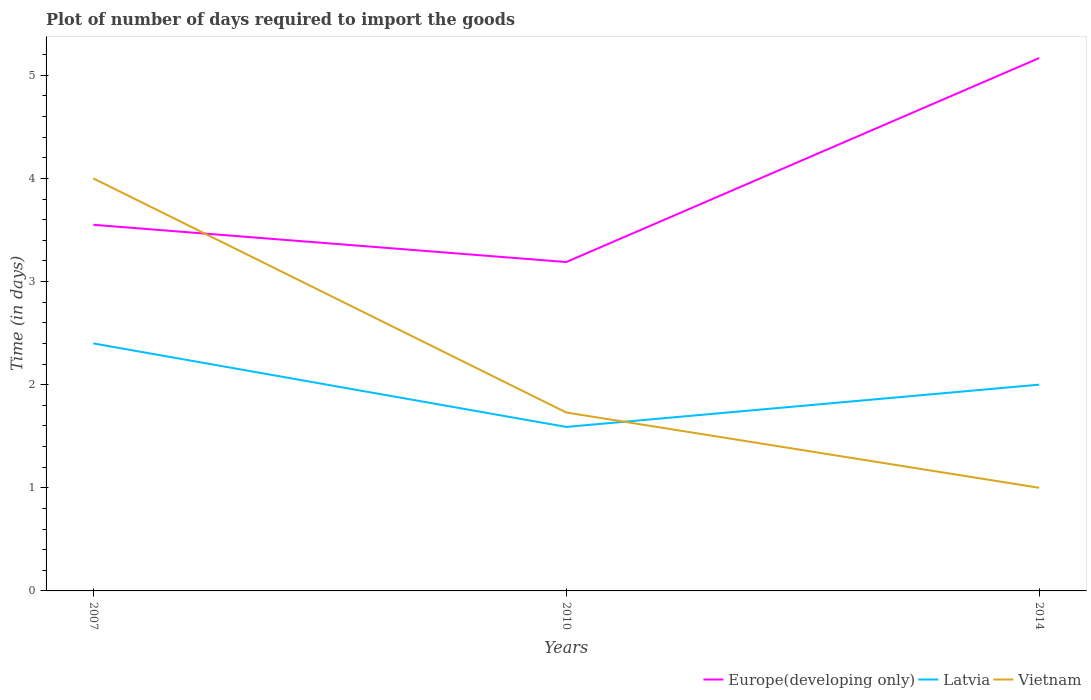How many different coloured lines are there?
Provide a succinct answer. 3. Does the line corresponding to Vietnam intersect with the line corresponding to Europe(developing only)?
Keep it short and to the point. Yes. Across all years, what is the maximum time required to import goods in Vietnam?
Offer a very short reply. 1. What is the total time required to import goods in Europe(developing only) in the graph?
Your response must be concise. 0.36. What is the difference between the highest and the second highest time required to import goods in Latvia?
Make the answer very short. 0.81. What is the difference between the highest and the lowest time required to import goods in Latvia?
Provide a succinct answer. 2. Is the time required to import goods in Europe(developing only) strictly greater than the time required to import goods in Latvia over the years?
Make the answer very short. No. How many years are there in the graph?
Offer a terse response. 3. Are the values on the major ticks of Y-axis written in scientific E-notation?
Keep it short and to the point. No. How many legend labels are there?
Your answer should be compact. 3. What is the title of the graph?
Ensure brevity in your answer.  Plot of number of days required to import the goods. What is the label or title of the X-axis?
Ensure brevity in your answer.  Years. What is the label or title of the Y-axis?
Your answer should be very brief. Time (in days). What is the Time (in days) in Europe(developing only) in 2007?
Offer a very short reply. 3.55. What is the Time (in days) of Latvia in 2007?
Give a very brief answer. 2.4. What is the Time (in days) of Europe(developing only) in 2010?
Give a very brief answer. 3.19. What is the Time (in days) in Latvia in 2010?
Make the answer very short. 1.59. What is the Time (in days) in Vietnam in 2010?
Ensure brevity in your answer.  1.73. What is the Time (in days) of Europe(developing only) in 2014?
Keep it short and to the point. 5.17. Across all years, what is the maximum Time (in days) in Europe(developing only)?
Provide a succinct answer. 5.17. Across all years, what is the maximum Time (in days) in Latvia?
Your response must be concise. 2.4. Across all years, what is the maximum Time (in days) of Vietnam?
Offer a terse response. 4. Across all years, what is the minimum Time (in days) of Europe(developing only)?
Ensure brevity in your answer.  3.19. Across all years, what is the minimum Time (in days) in Latvia?
Your answer should be very brief. 1.59. What is the total Time (in days) of Europe(developing only) in the graph?
Your answer should be compact. 11.91. What is the total Time (in days) of Latvia in the graph?
Your answer should be compact. 5.99. What is the total Time (in days) in Vietnam in the graph?
Your answer should be very brief. 6.73. What is the difference between the Time (in days) of Europe(developing only) in 2007 and that in 2010?
Provide a short and direct response. 0.36. What is the difference between the Time (in days) of Latvia in 2007 and that in 2010?
Make the answer very short. 0.81. What is the difference between the Time (in days) in Vietnam in 2007 and that in 2010?
Keep it short and to the point. 2.27. What is the difference between the Time (in days) in Europe(developing only) in 2007 and that in 2014?
Give a very brief answer. -1.62. What is the difference between the Time (in days) of Europe(developing only) in 2010 and that in 2014?
Give a very brief answer. -1.98. What is the difference between the Time (in days) in Latvia in 2010 and that in 2014?
Provide a succinct answer. -0.41. What is the difference between the Time (in days) of Vietnam in 2010 and that in 2014?
Provide a short and direct response. 0.73. What is the difference between the Time (in days) in Europe(developing only) in 2007 and the Time (in days) in Latvia in 2010?
Your answer should be very brief. 1.96. What is the difference between the Time (in days) of Europe(developing only) in 2007 and the Time (in days) of Vietnam in 2010?
Your answer should be very brief. 1.82. What is the difference between the Time (in days) in Latvia in 2007 and the Time (in days) in Vietnam in 2010?
Your answer should be compact. 0.67. What is the difference between the Time (in days) of Europe(developing only) in 2007 and the Time (in days) of Latvia in 2014?
Ensure brevity in your answer.  1.55. What is the difference between the Time (in days) of Europe(developing only) in 2007 and the Time (in days) of Vietnam in 2014?
Offer a very short reply. 2.55. What is the difference between the Time (in days) of Europe(developing only) in 2010 and the Time (in days) of Latvia in 2014?
Offer a terse response. 1.19. What is the difference between the Time (in days) in Europe(developing only) in 2010 and the Time (in days) in Vietnam in 2014?
Offer a very short reply. 2.19. What is the difference between the Time (in days) of Latvia in 2010 and the Time (in days) of Vietnam in 2014?
Make the answer very short. 0.59. What is the average Time (in days) in Europe(developing only) per year?
Offer a very short reply. 3.97. What is the average Time (in days) of Latvia per year?
Your answer should be compact. 2. What is the average Time (in days) of Vietnam per year?
Your answer should be very brief. 2.24. In the year 2007, what is the difference between the Time (in days) in Europe(developing only) and Time (in days) in Latvia?
Provide a short and direct response. 1.15. In the year 2007, what is the difference between the Time (in days) in Europe(developing only) and Time (in days) in Vietnam?
Give a very brief answer. -0.45. In the year 2007, what is the difference between the Time (in days) in Latvia and Time (in days) in Vietnam?
Make the answer very short. -1.6. In the year 2010, what is the difference between the Time (in days) in Europe(developing only) and Time (in days) in Latvia?
Your answer should be compact. 1.6. In the year 2010, what is the difference between the Time (in days) of Europe(developing only) and Time (in days) of Vietnam?
Your answer should be compact. 1.46. In the year 2010, what is the difference between the Time (in days) of Latvia and Time (in days) of Vietnam?
Your response must be concise. -0.14. In the year 2014, what is the difference between the Time (in days) in Europe(developing only) and Time (in days) in Latvia?
Offer a very short reply. 3.17. In the year 2014, what is the difference between the Time (in days) of Europe(developing only) and Time (in days) of Vietnam?
Keep it short and to the point. 4.17. What is the ratio of the Time (in days) of Europe(developing only) in 2007 to that in 2010?
Your response must be concise. 1.11. What is the ratio of the Time (in days) of Latvia in 2007 to that in 2010?
Keep it short and to the point. 1.51. What is the ratio of the Time (in days) of Vietnam in 2007 to that in 2010?
Your answer should be compact. 2.31. What is the ratio of the Time (in days) in Europe(developing only) in 2007 to that in 2014?
Offer a very short reply. 0.69. What is the ratio of the Time (in days) of Europe(developing only) in 2010 to that in 2014?
Your answer should be very brief. 0.62. What is the ratio of the Time (in days) of Latvia in 2010 to that in 2014?
Make the answer very short. 0.8. What is the ratio of the Time (in days) in Vietnam in 2010 to that in 2014?
Provide a succinct answer. 1.73. What is the difference between the highest and the second highest Time (in days) in Europe(developing only)?
Your response must be concise. 1.62. What is the difference between the highest and the second highest Time (in days) in Vietnam?
Your answer should be very brief. 2.27. What is the difference between the highest and the lowest Time (in days) in Europe(developing only)?
Your answer should be compact. 1.98. What is the difference between the highest and the lowest Time (in days) of Latvia?
Offer a terse response. 0.81. What is the difference between the highest and the lowest Time (in days) in Vietnam?
Ensure brevity in your answer.  3. 